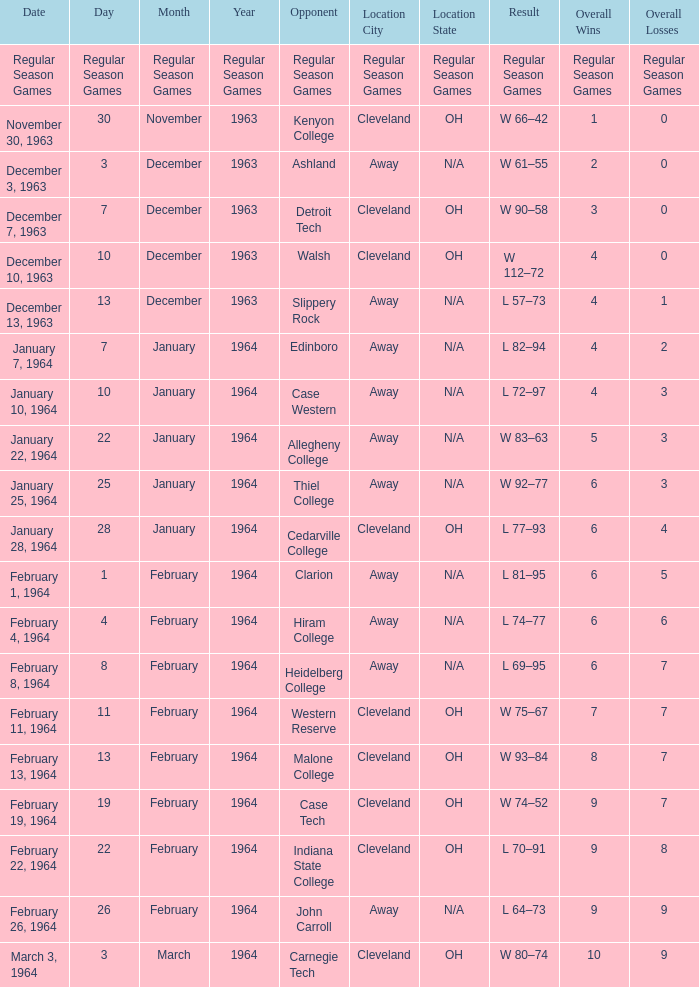Would you be able to parse every entry in this table? {'header': ['Date', 'Day', 'Month', 'Year', 'Opponent', 'Location City', 'Location State', 'Result', 'Overall Wins', 'Overall Losses'], 'rows': [['Regular Season Games', 'Regular Season Games', 'Regular Season Games', 'Regular Season Games', 'Regular Season Games', 'Regular Season Games', 'Regular Season Games', 'Regular Season Games', 'Regular Season Games', 'Regular Season Games'], ['November 30, 1963', '30', 'November', '1963', 'Kenyon College', 'Cleveland', 'OH', 'W 66–42', '1', '0'], ['December 3, 1963', '3', 'December', '1963', 'Ashland', 'Away', 'N/A', 'W 61–55', '2', '0'], ['December 7, 1963', '7', 'December', '1963', 'Detroit Tech', 'Cleveland', 'OH', 'W 90–58', '3', '0'], ['December 10, 1963', '10', 'December', '1963', 'Walsh', 'Cleveland', 'OH', 'W 112–72', '4', '0'], ['December 13, 1963', '13', 'December', '1963', 'Slippery Rock', 'Away', 'N/A', 'L 57–73', '4', '1'], ['January 7, 1964', '7', 'January', '1964', 'Edinboro', 'Away', 'N/A', 'L 82–94', '4', '2'], ['January 10, 1964', '10', 'January', '1964', 'Case Western', 'Away', 'N/A', 'L 72–97', '4', '3'], ['January 22, 1964', '22', 'January', '1964', 'Allegheny College', 'Away', 'N/A', 'W 83–63', '5', '3'], ['January 25, 1964', '25', 'January', '1964', 'Thiel College', 'Away', 'N/A', 'W 92–77', '6', '3'], ['January 28, 1964', '28', 'January', '1964', 'Cedarville College', 'Cleveland', 'OH', 'L 77–93', '6', '4'], ['February 1, 1964', '1', 'February', '1964', 'Clarion', 'Away', 'N/A', 'L 81–95', '6', '5'], ['February 4, 1964', '4', 'February', '1964', 'Hiram College', 'Away', 'N/A', 'L 74–77', '6', '6'], ['February 8, 1964', '8', 'February', '1964', 'Heidelberg College', 'Away', 'N/A', 'L 69–95', '6', '7'], ['February 11, 1964', '11', 'February', '1964', 'Western Reserve', 'Cleveland', 'OH', 'W 75–67', '7', '7'], ['February 13, 1964', '13', 'February', '1964', 'Malone College', 'Cleveland', 'OH', 'W 93–84', '8', '7'], ['February 19, 1964', '19', 'February', '1964', 'Case Tech', 'Cleveland', 'OH', 'W 74–52', '9', '7'], ['February 22, 1964', '22', 'February', '1964', 'Indiana State College', 'Cleveland', 'OH', 'L 70–91', '9', '8'], ['February 26, 1964', '26', 'February', '1964', 'John Carroll', 'Away', 'N/A', 'L 64–73', '9', '9'], ['March 3, 1964', '3', 'March', '1964', 'Carnegie Tech', 'Cleveland', 'OH', 'W 80–74', '10', '9']]} What is the Overall with a Date that is february 4, 1964? 6–6. 